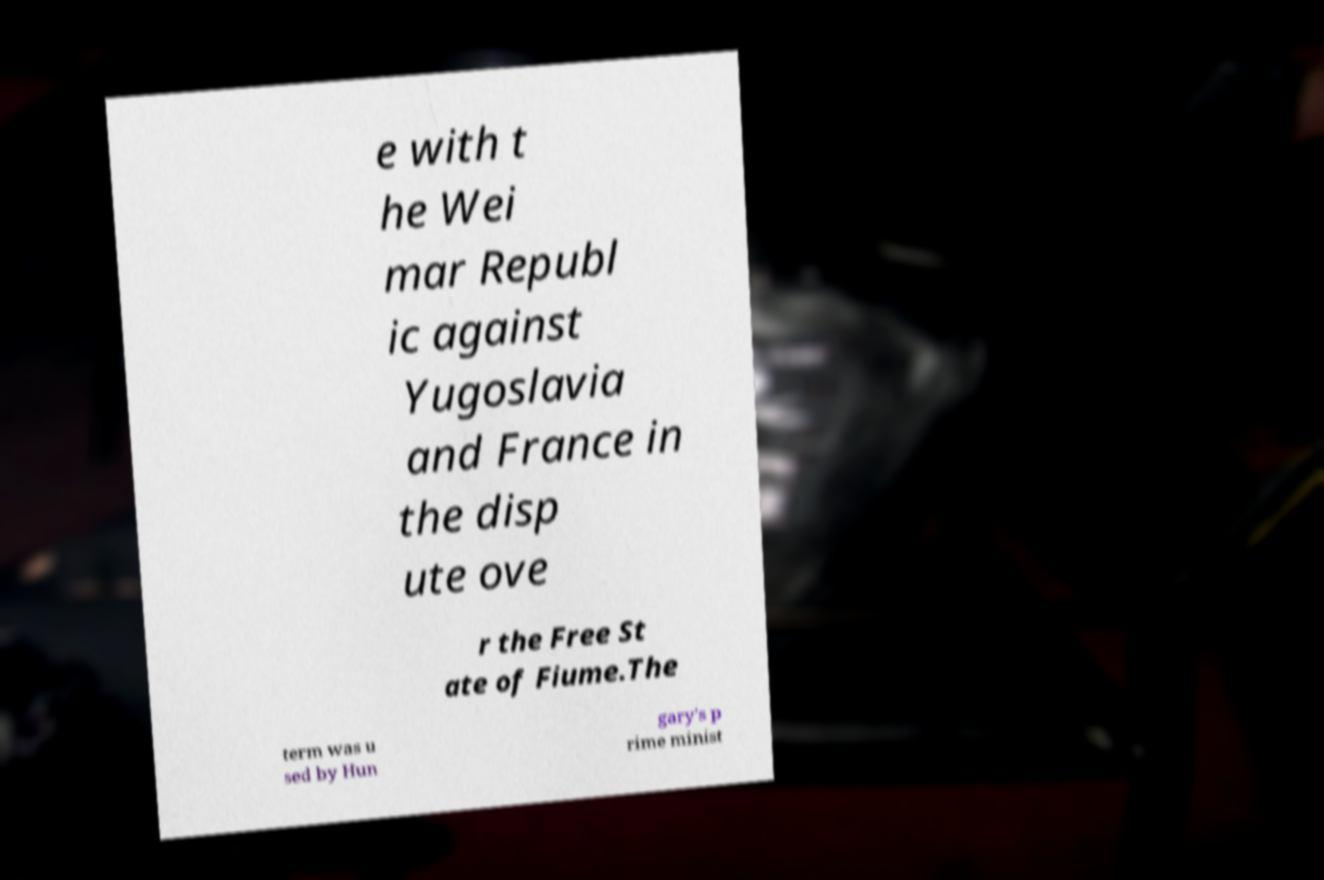What messages or text are displayed in this image? I need them in a readable, typed format. e with t he Wei mar Republ ic against Yugoslavia and France in the disp ute ove r the Free St ate of Fiume.The term was u sed by Hun gary's p rime minist 